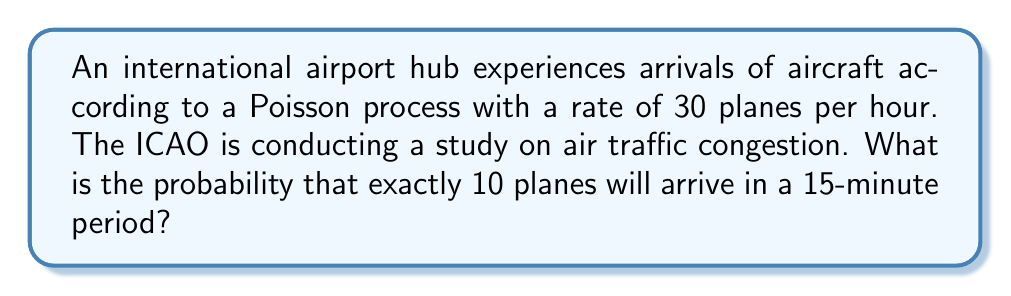Help me with this question. Let's approach this step-by-step:

1) First, we need to determine the rate parameter λ for a 15-minute period.
   The given rate is 30 planes per hour, so for 15 minutes (1/4 of an hour):
   λ = 30 * (1/4) = 7.5 planes per 15 minutes

2) We're looking for the probability of exactly 10 arrivals in this 15-minute period.
   This follows a Poisson distribution with λ = 7.5.

3) The probability mass function for a Poisson distribution is:

   $$P(X = k) = \frac{e^{-λ} λ^k}{k!}$$

   Where k is the number of occurrences we're interested in (10 in this case).

4) Substituting our values:

   $$P(X = 10) = \frac{e^{-7.5} 7.5^{10}}{10!}$$

5) Calculating this:
   
   $$P(X = 10) = \frac{e^{-7.5} * 7.5^{10}}{3628800} \approx 0.0574$$

6) Converting to a percentage:
   0.0574 * 100 ≈ 5.74%

Thus, the probability of exactly 10 planes arriving in a 15-minute period is approximately 5.74%.
Answer: 5.74% 